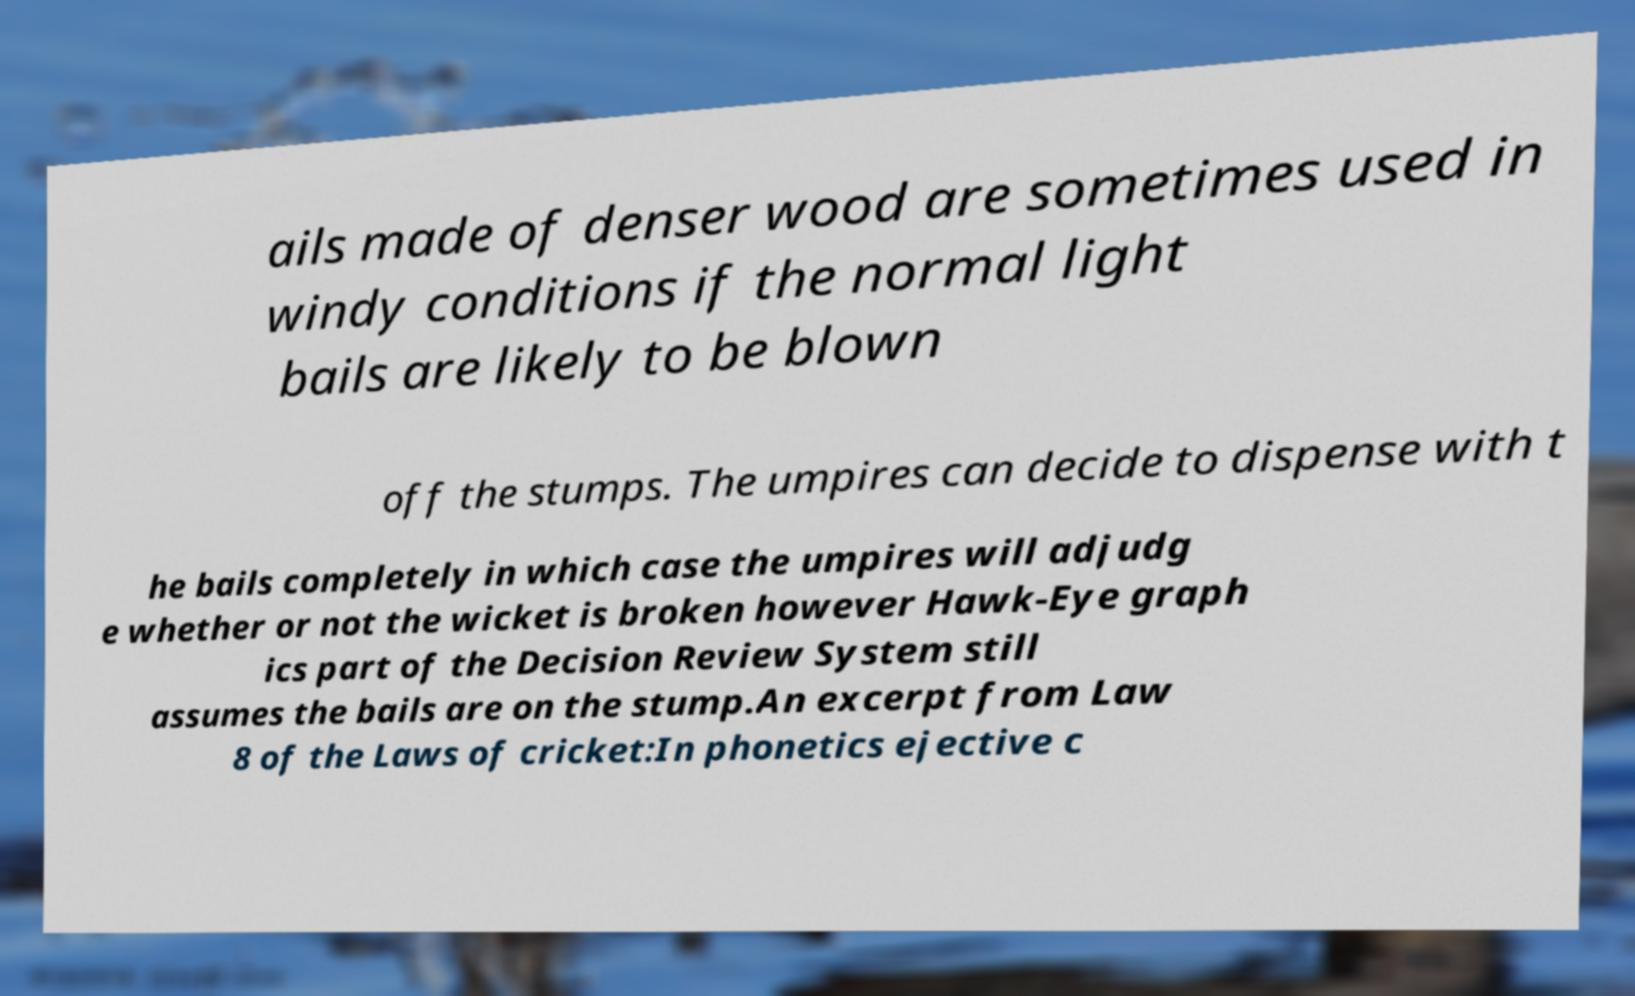Can you read and provide the text displayed in the image?This photo seems to have some interesting text. Can you extract and type it out for me? ails made of denser wood are sometimes used in windy conditions if the normal light bails are likely to be blown off the stumps. The umpires can decide to dispense with t he bails completely in which case the umpires will adjudg e whether or not the wicket is broken however Hawk-Eye graph ics part of the Decision Review System still assumes the bails are on the stump.An excerpt from Law 8 of the Laws of cricket:In phonetics ejective c 